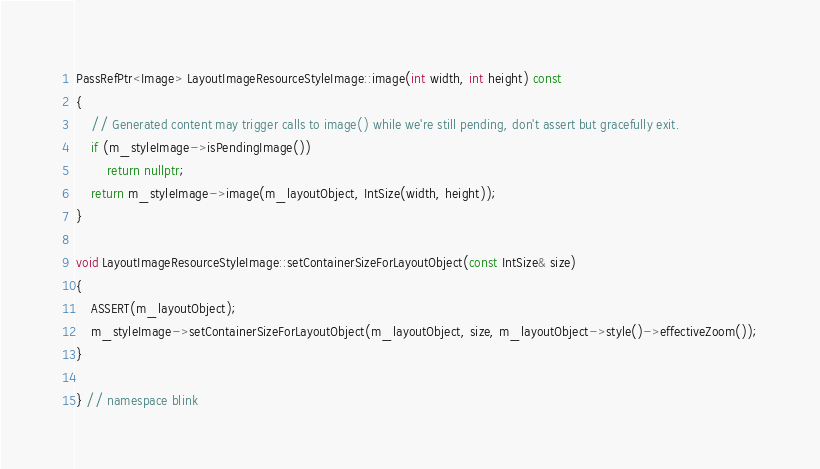Convert code to text. <code><loc_0><loc_0><loc_500><loc_500><_C++_>PassRefPtr<Image> LayoutImageResourceStyleImage::image(int width, int height) const
{
    // Generated content may trigger calls to image() while we're still pending, don't assert but gracefully exit.
    if (m_styleImage->isPendingImage())
        return nullptr;
    return m_styleImage->image(m_layoutObject, IntSize(width, height));
}

void LayoutImageResourceStyleImage::setContainerSizeForLayoutObject(const IntSize& size)
{
    ASSERT(m_layoutObject);
    m_styleImage->setContainerSizeForLayoutObject(m_layoutObject, size, m_layoutObject->style()->effectiveZoom());
}

} // namespace blink
</code> 